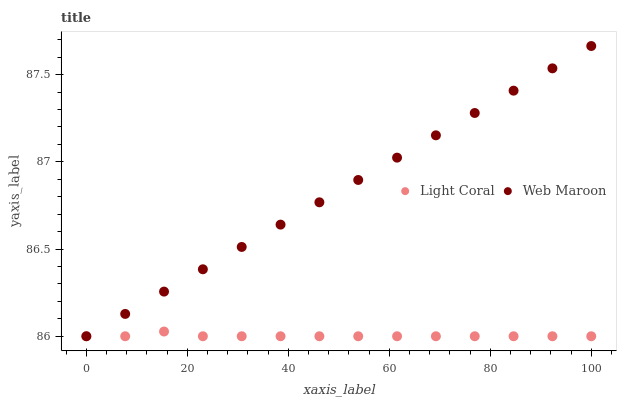Does Light Coral have the minimum area under the curve?
Answer yes or no. Yes. Does Web Maroon have the maximum area under the curve?
Answer yes or no. Yes. Does Web Maroon have the minimum area under the curve?
Answer yes or no. No. Is Web Maroon the smoothest?
Answer yes or no. Yes. Is Light Coral the roughest?
Answer yes or no. Yes. Is Web Maroon the roughest?
Answer yes or no. No. Does Light Coral have the lowest value?
Answer yes or no. Yes. Does Web Maroon have the highest value?
Answer yes or no. Yes. Does Light Coral intersect Web Maroon?
Answer yes or no. Yes. Is Light Coral less than Web Maroon?
Answer yes or no. No. Is Light Coral greater than Web Maroon?
Answer yes or no. No. 